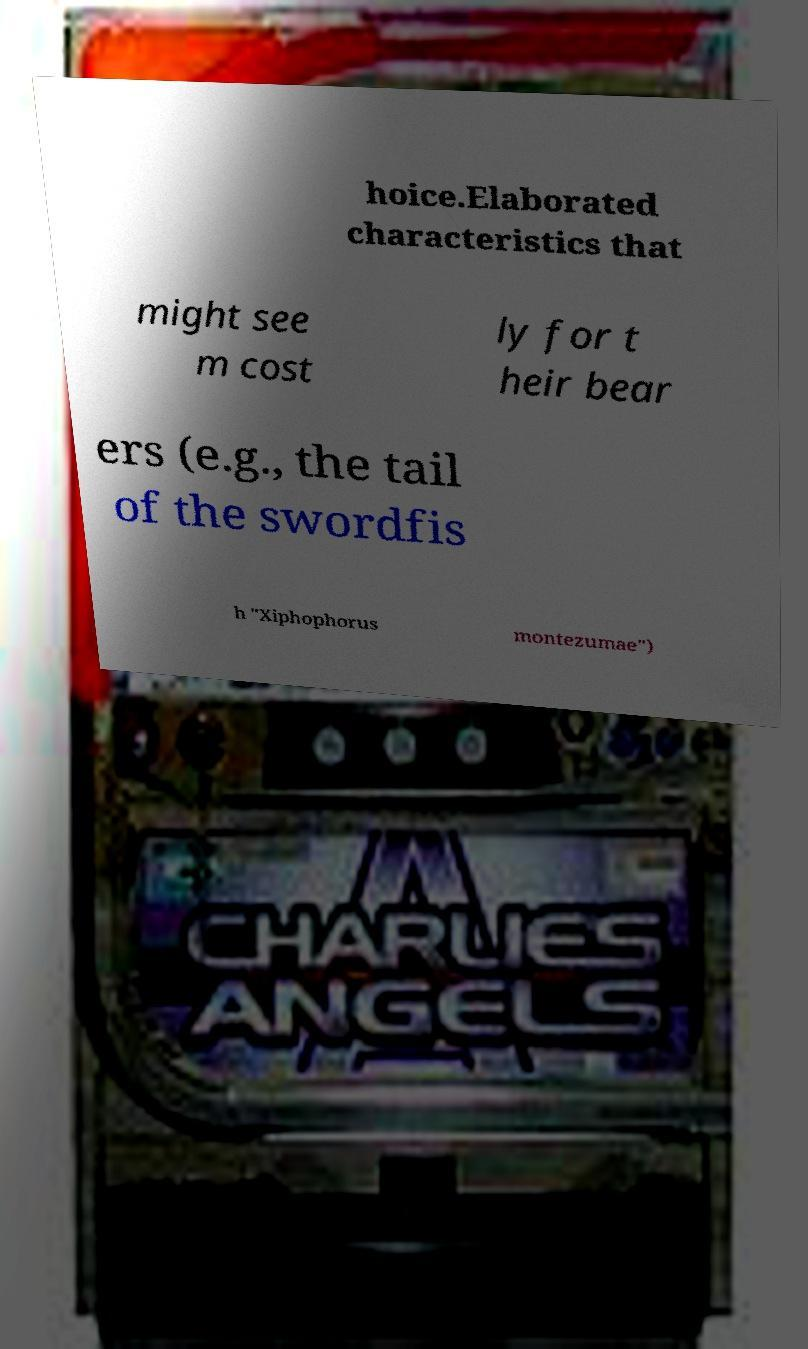For documentation purposes, I need the text within this image transcribed. Could you provide that? hoice.Elaborated characteristics that might see m cost ly for t heir bear ers (e.g., the tail of the swordfis h "Xiphophorus montezumae") 